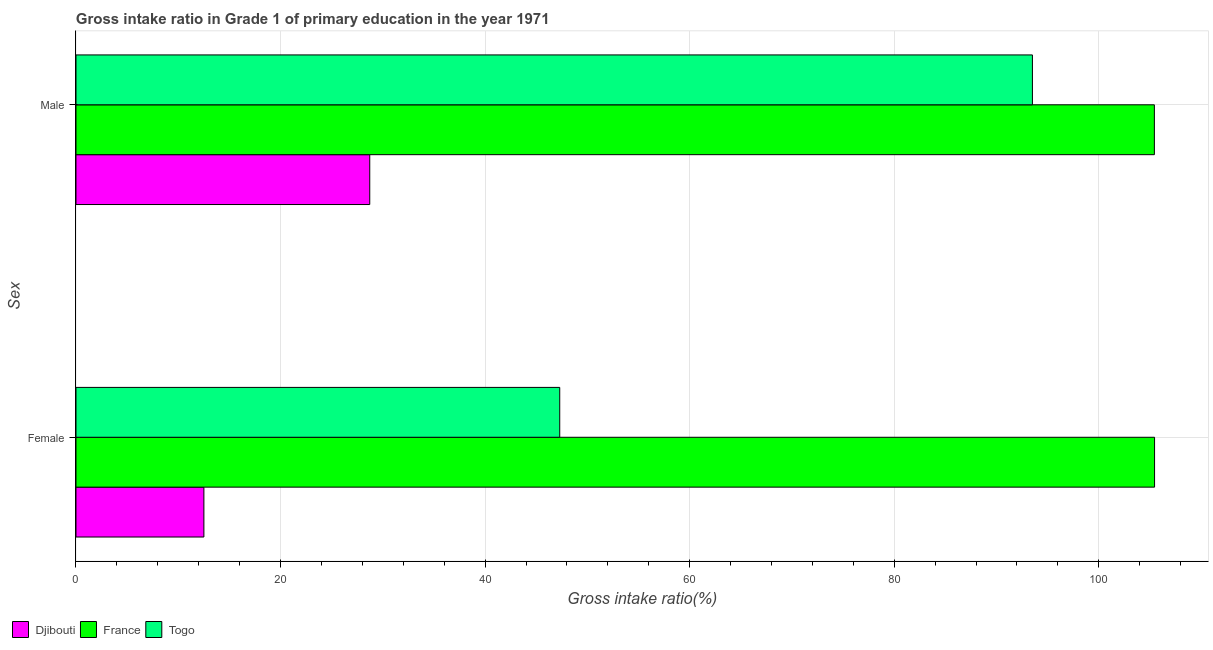How many different coloured bars are there?
Ensure brevity in your answer.  3. How many bars are there on the 2nd tick from the bottom?
Your answer should be compact. 3. What is the gross intake ratio(male) in Djibouti?
Provide a short and direct response. 28.72. Across all countries, what is the maximum gross intake ratio(male)?
Ensure brevity in your answer.  105.43. Across all countries, what is the minimum gross intake ratio(male)?
Your response must be concise. 28.72. In which country was the gross intake ratio(female) maximum?
Your answer should be compact. France. In which country was the gross intake ratio(female) minimum?
Your answer should be compact. Djibouti. What is the total gross intake ratio(male) in the graph?
Provide a short and direct response. 227.66. What is the difference between the gross intake ratio(male) in Djibouti and that in France?
Make the answer very short. -76.71. What is the difference between the gross intake ratio(male) in France and the gross intake ratio(female) in Togo?
Offer a very short reply. 58.14. What is the average gross intake ratio(female) per country?
Provide a short and direct response. 55.08. What is the difference between the gross intake ratio(male) and gross intake ratio(female) in Togo?
Your response must be concise. 46.21. In how many countries, is the gross intake ratio(female) greater than 76 %?
Your answer should be compact. 1. What is the ratio of the gross intake ratio(male) in Djibouti to that in France?
Give a very brief answer. 0.27. How many bars are there?
Your response must be concise. 6. How many countries are there in the graph?
Your answer should be compact. 3. Does the graph contain any zero values?
Give a very brief answer. No. How are the legend labels stacked?
Offer a terse response. Horizontal. What is the title of the graph?
Provide a succinct answer. Gross intake ratio in Grade 1 of primary education in the year 1971. Does "Indonesia" appear as one of the legend labels in the graph?
Give a very brief answer. No. What is the label or title of the X-axis?
Give a very brief answer. Gross intake ratio(%). What is the label or title of the Y-axis?
Ensure brevity in your answer.  Sex. What is the Gross intake ratio(%) in Djibouti in Female?
Make the answer very short. 12.51. What is the Gross intake ratio(%) of France in Female?
Give a very brief answer. 105.45. What is the Gross intake ratio(%) in Togo in Female?
Give a very brief answer. 47.3. What is the Gross intake ratio(%) in Djibouti in Male?
Offer a terse response. 28.72. What is the Gross intake ratio(%) of France in Male?
Offer a very short reply. 105.43. What is the Gross intake ratio(%) in Togo in Male?
Give a very brief answer. 93.51. Across all Sex, what is the maximum Gross intake ratio(%) in Djibouti?
Provide a succinct answer. 28.72. Across all Sex, what is the maximum Gross intake ratio(%) of France?
Your response must be concise. 105.45. Across all Sex, what is the maximum Gross intake ratio(%) of Togo?
Your answer should be very brief. 93.51. Across all Sex, what is the minimum Gross intake ratio(%) in Djibouti?
Provide a short and direct response. 12.51. Across all Sex, what is the minimum Gross intake ratio(%) in France?
Your answer should be compact. 105.43. Across all Sex, what is the minimum Gross intake ratio(%) in Togo?
Give a very brief answer. 47.3. What is the total Gross intake ratio(%) of Djibouti in the graph?
Offer a very short reply. 41.23. What is the total Gross intake ratio(%) in France in the graph?
Make the answer very short. 210.89. What is the total Gross intake ratio(%) in Togo in the graph?
Your answer should be compact. 140.81. What is the difference between the Gross intake ratio(%) of Djibouti in Female and that in Male?
Your answer should be very brief. -16.22. What is the difference between the Gross intake ratio(%) of France in Female and that in Male?
Your answer should be very brief. 0.02. What is the difference between the Gross intake ratio(%) in Togo in Female and that in Male?
Your answer should be very brief. -46.21. What is the difference between the Gross intake ratio(%) of Djibouti in Female and the Gross intake ratio(%) of France in Male?
Give a very brief answer. -92.93. What is the difference between the Gross intake ratio(%) in Djibouti in Female and the Gross intake ratio(%) in Togo in Male?
Give a very brief answer. -81. What is the difference between the Gross intake ratio(%) in France in Female and the Gross intake ratio(%) in Togo in Male?
Your answer should be compact. 11.94. What is the average Gross intake ratio(%) of Djibouti per Sex?
Offer a very short reply. 20.61. What is the average Gross intake ratio(%) of France per Sex?
Your response must be concise. 105.44. What is the average Gross intake ratio(%) in Togo per Sex?
Your answer should be compact. 70.4. What is the difference between the Gross intake ratio(%) in Djibouti and Gross intake ratio(%) in France in Female?
Make the answer very short. -92.95. What is the difference between the Gross intake ratio(%) in Djibouti and Gross intake ratio(%) in Togo in Female?
Provide a short and direct response. -34.79. What is the difference between the Gross intake ratio(%) of France and Gross intake ratio(%) of Togo in Female?
Keep it short and to the point. 58.16. What is the difference between the Gross intake ratio(%) in Djibouti and Gross intake ratio(%) in France in Male?
Provide a succinct answer. -76.71. What is the difference between the Gross intake ratio(%) in Djibouti and Gross intake ratio(%) in Togo in Male?
Your answer should be compact. -64.79. What is the difference between the Gross intake ratio(%) in France and Gross intake ratio(%) in Togo in Male?
Keep it short and to the point. 11.92. What is the ratio of the Gross intake ratio(%) in Djibouti in Female to that in Male?
Your response must be concise. 0.44. What is the ratio of the Gross intake ratio(%) of Togo in Female to that in Male?
Make the answer very short. 0.51. What is the difference between the highest and the second highest Gross intake ratio(%) of Djibouti?
Offer a terse response. 16.22. What is the difference between the highest and the second highest Gross intake ratio(%) of France?
Offer a terse response. 0.02. What is the difference between the highest and the second highest Gross intake ratio(%) in Togo?
Your response must be concise. 46.21. What is the difference between the highest and the lowest Gross intake ratio(%) of Djibouti?
Your answer should be compact. 16.22. What is the difference between the highest and the lowest Gross intake ratio(%) in France?
Offer a terse response. 0.02. What is the difference between the highest and the lowest Gross intake ratio(%) in Togo?
Provide a succinct answer. 46.21. 